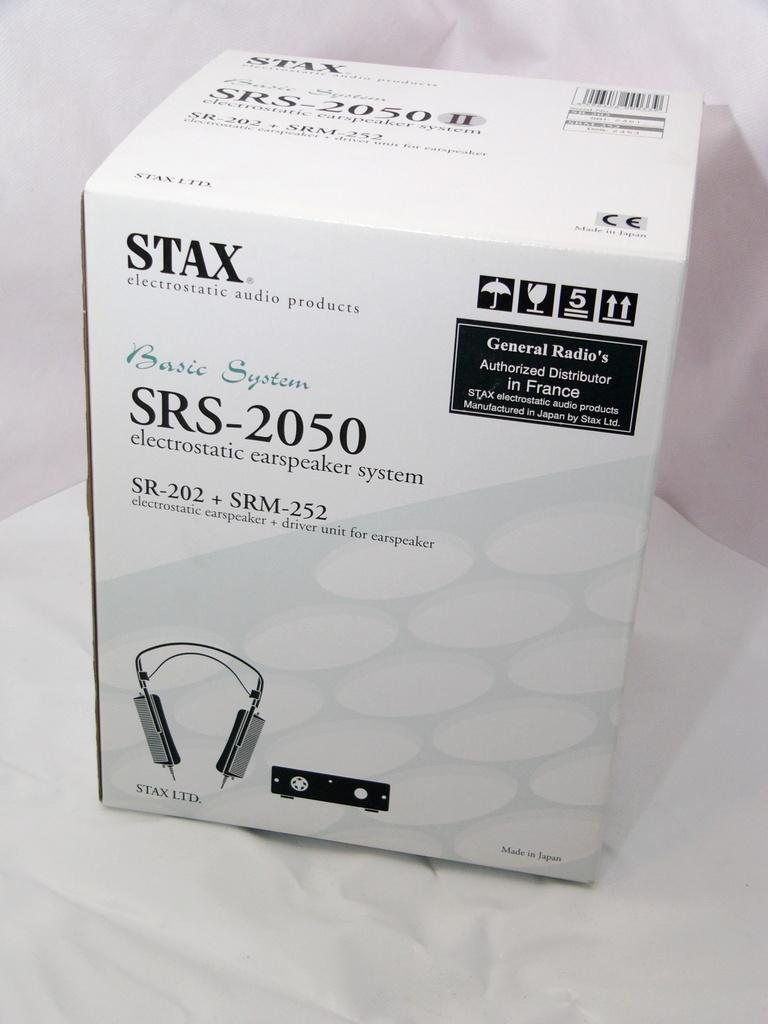<image>
Summarize the visual content of the image. The box contains a STAX brand carspeaker system. 